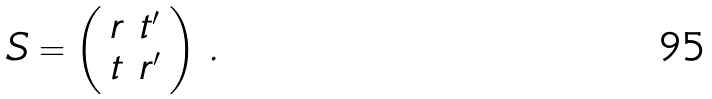Convert formula to latex. <formula><loc_0><loc_0><loc_500><loc_500>S = \left ( \begin{array} { l l } r & t ^ { \prime } \\ t & r ^ { \prime } \end{array} \right ) \, .</formula> 